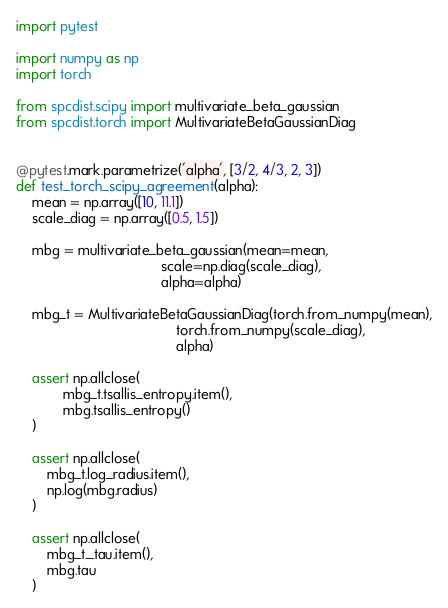Convert code to text. <code><loc_0><loc_0><loc_500><loc_500><_Python_>import pytest

import numpy as np
import torch

from spcdist.scipy import multivariate_beta_gaussian
from spcdist.torch import MultivariateBetaGaussianDiag


@pytest.mark.parametrize('alpha', [3/2, 4/3, 2, 3])
def test_torch_scipy_agreement(alpha):
    mean = np.array([10, 11.1])
    scale_diag = np.array([0.5, 1.5])

    mbg = multivariate_beta_gaussian(mean=mean,
                                     scale=np.diag(scale_diag),
                                     alpha=alpha)

    mbg_t = MultivariateBetaGaussianDiag(torch.from_numpy(mean),
                                         torch.from_numpy(scale_diag),
                                         alpha)

    assert np.allclose(
            mbg_t.tsallis_entropy.item(),
            mbg.tsallis_entropy()
    )

    assert np.allclose(
        mbg_t.log_radius.item(),
        np.log(mbg.radius)
    )

    assert np.allclose(
        mbg_t._tau.item(),
        mbg.tau
    )
</code> 